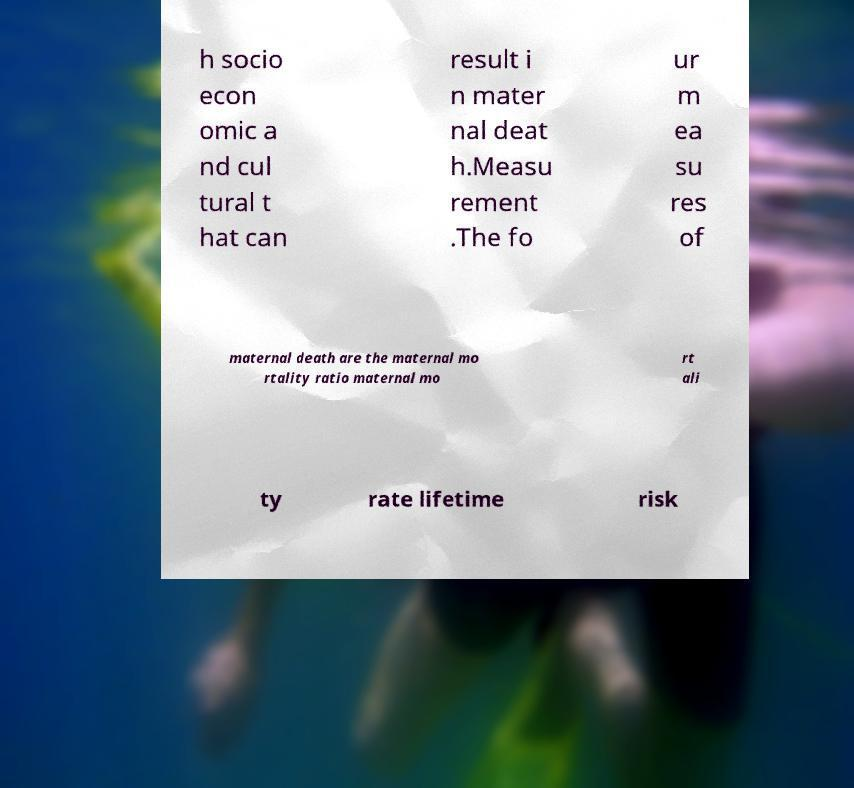Could you assist in decoding the text presented in this image and type it out clearly? h socio econ omic a nd cul tural t hat can result i n mater nal deat h.Measu rement .The fo ur m ea su res of maternal death are the maternal mo rtality ratio maternal mo rt ali ty rate lifetime risk 